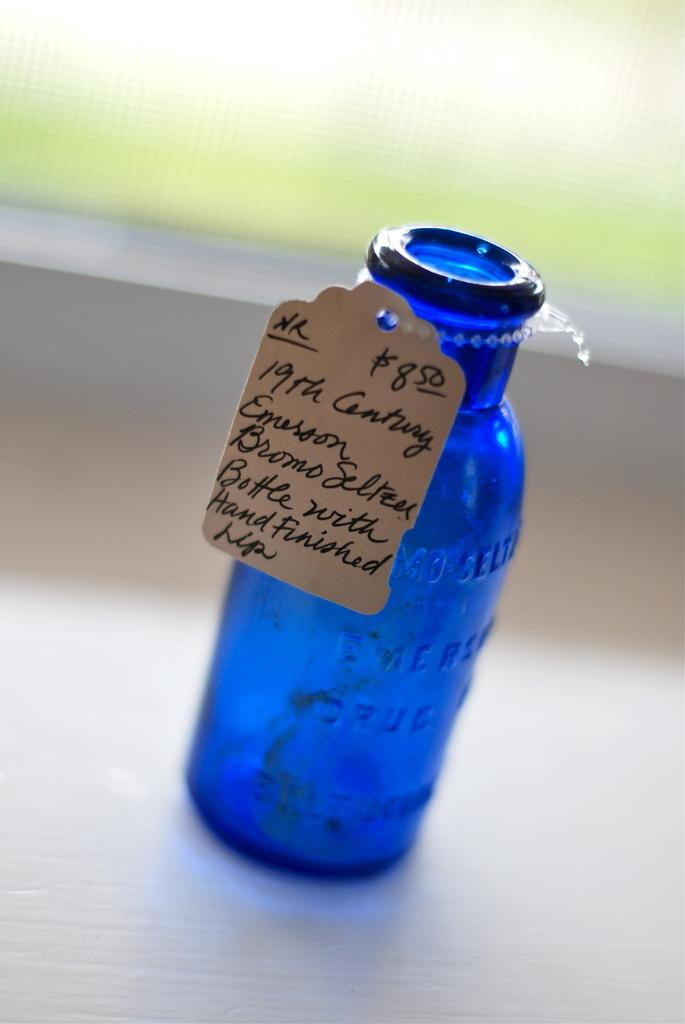<image>
Share a concise interpretation of the image provided. A blue bottle that is from the nineteenth century. 